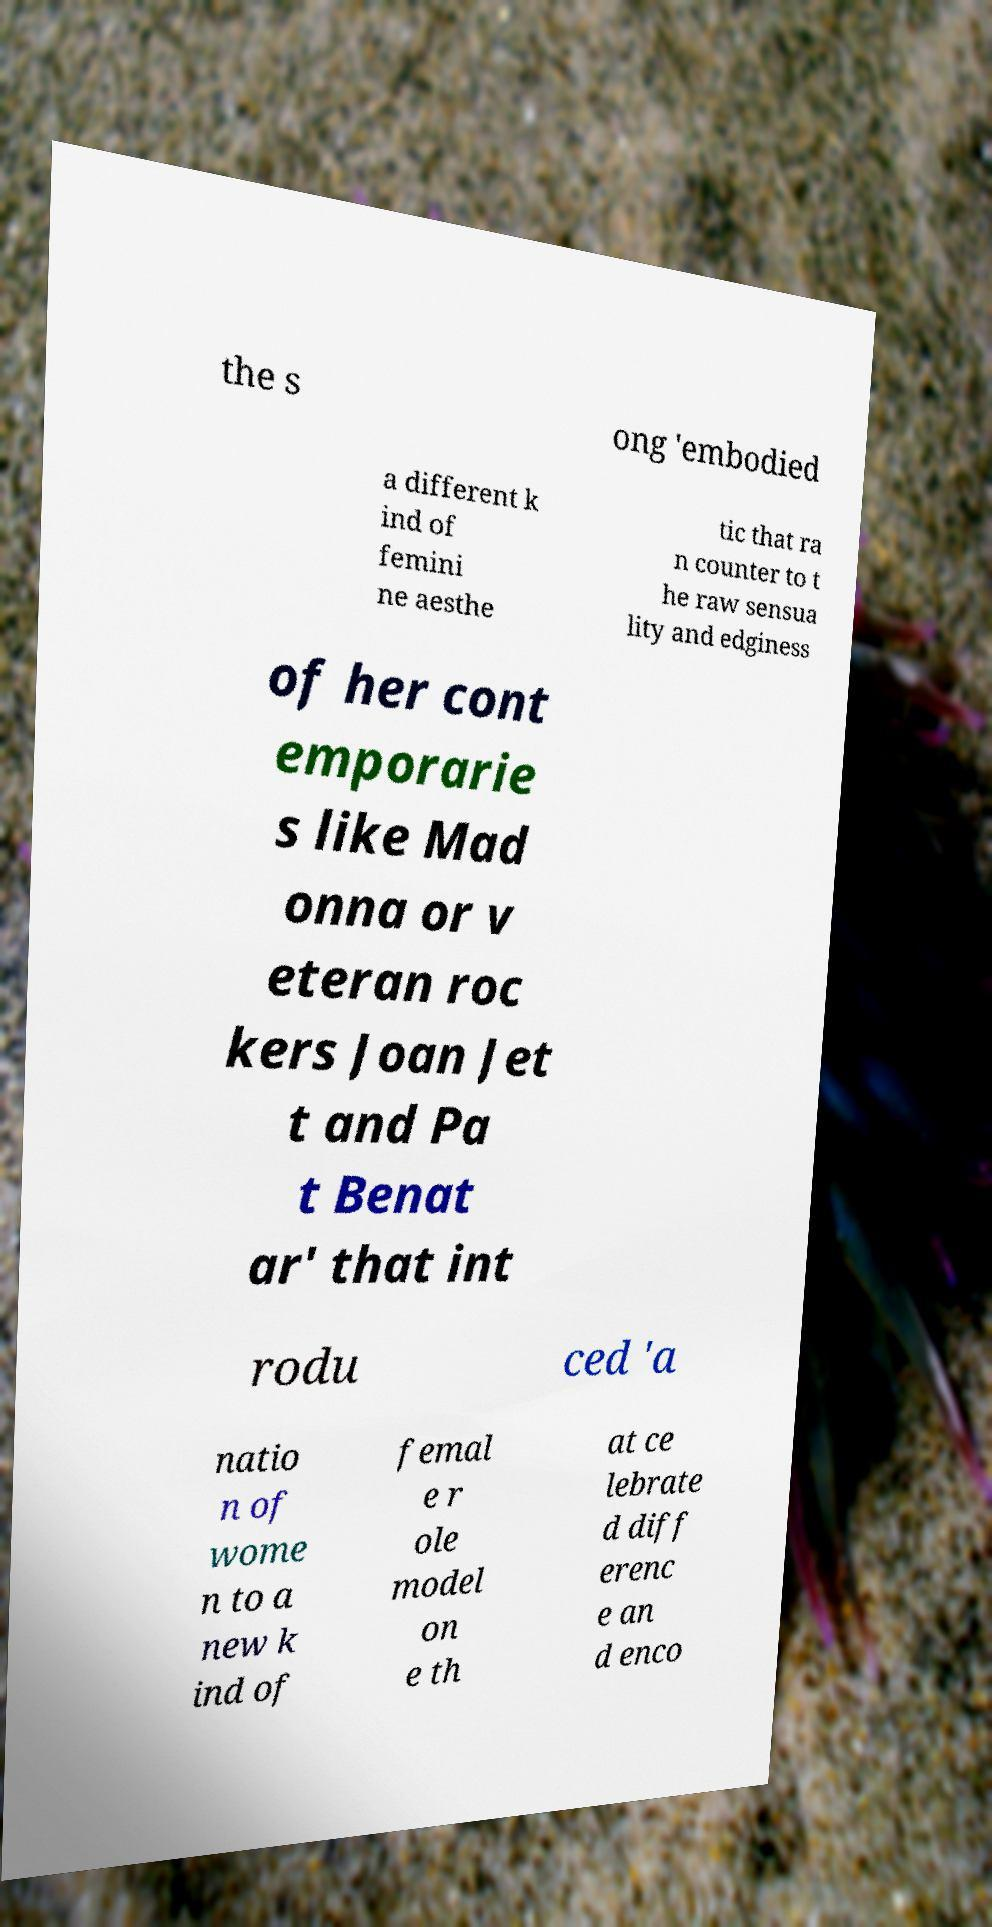Could you extract and type out the text from this image? the s ong 'embodied a different k ind of femini ne aesthe tic that ra n counter to t he raw sensua lity and edginess of her cont emporarie s like Mad onna or v eteran roc kers Joan Jet t and Pa t Benat ar' that int rodu ced 'a natio n of wome n to a new k ind of femal e r ole model on e th at ce lebrate d diff erenc e an d enco 